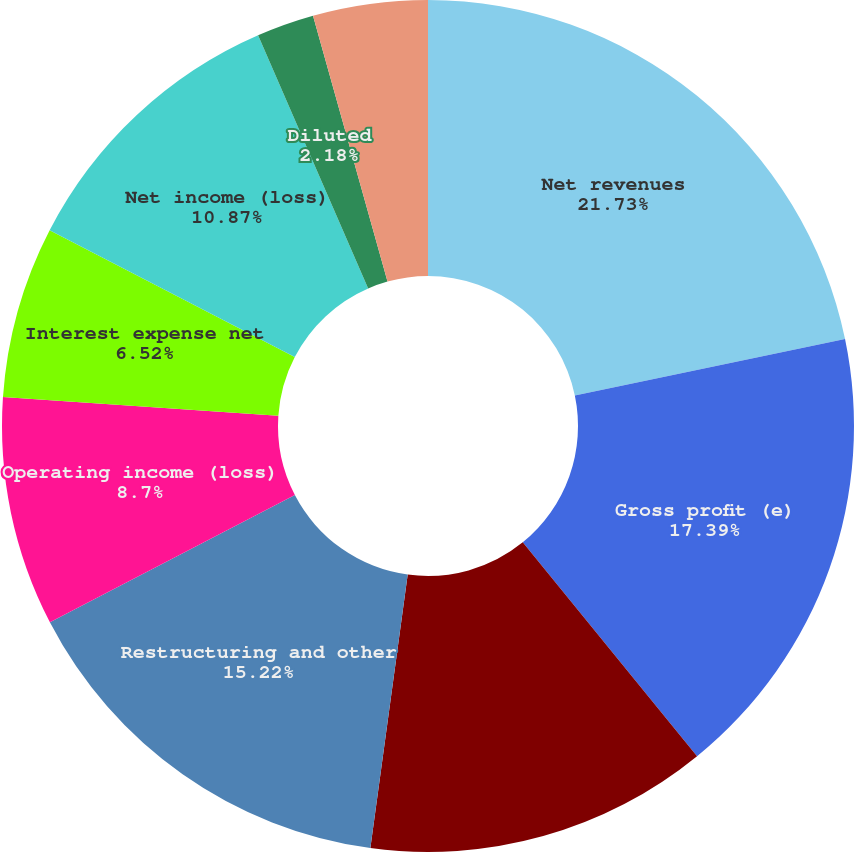Convert chart to OTSL. <chart><loc_0><loc_0><loc_500><loc_500><pie_chart><fcel>Net revenues<fcel>Gross profit (e)<fcel>Impairment of assets<fcel>Restructuring and other<fcel>Operating income (loss)<fcel>Interest expense net<fcel>Net income (loss)<fcel>Basic<fcel>Diluted<fcel>Dividends declared per common<nl><fcel>21.73%<fcel>17.39%<fcel>13.04%<fcel>15.22%<fcel>8.7%<fcel>6.52%<fcel>10.87%<fcel>0.0%<fcel>2.18%<fcel>4.35%<nl></chart> 